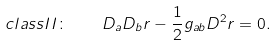<formula> <loc_0><loc_0><loc_500><loc_500>c l a s s I I \colon \quad D _ { a } D _ { b } r - \frac { 1 } { 2 } g _ { a b } D ^ { 2 } r = 0 .</formula> 